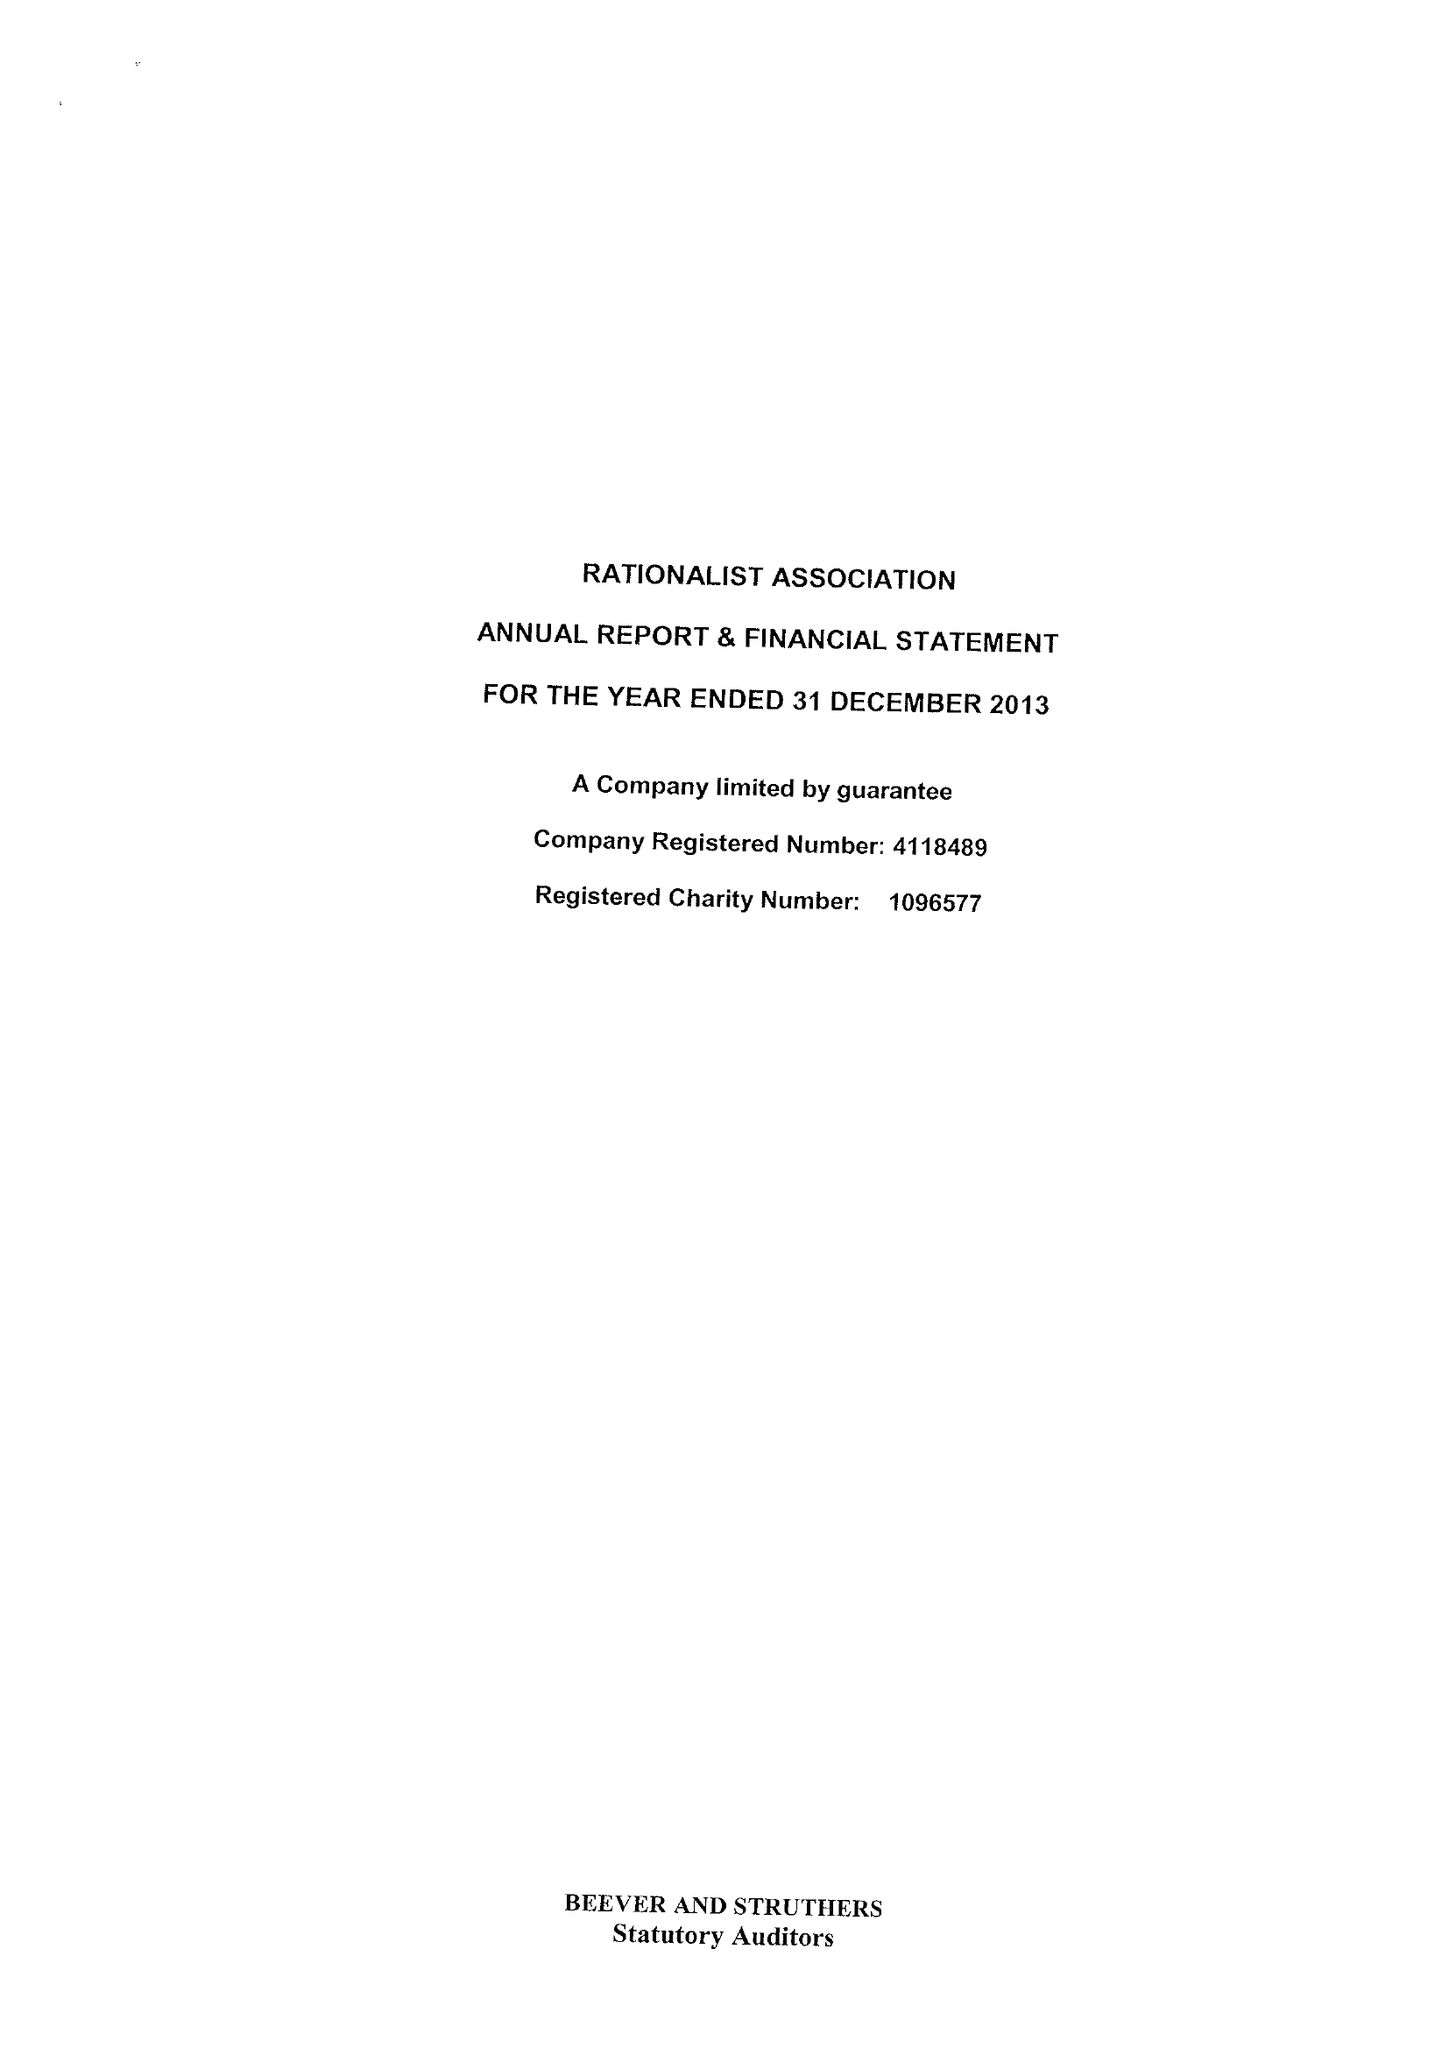What is the value for the charity_name?
Answer the question using a single word or phrase. The Rationalist Association 